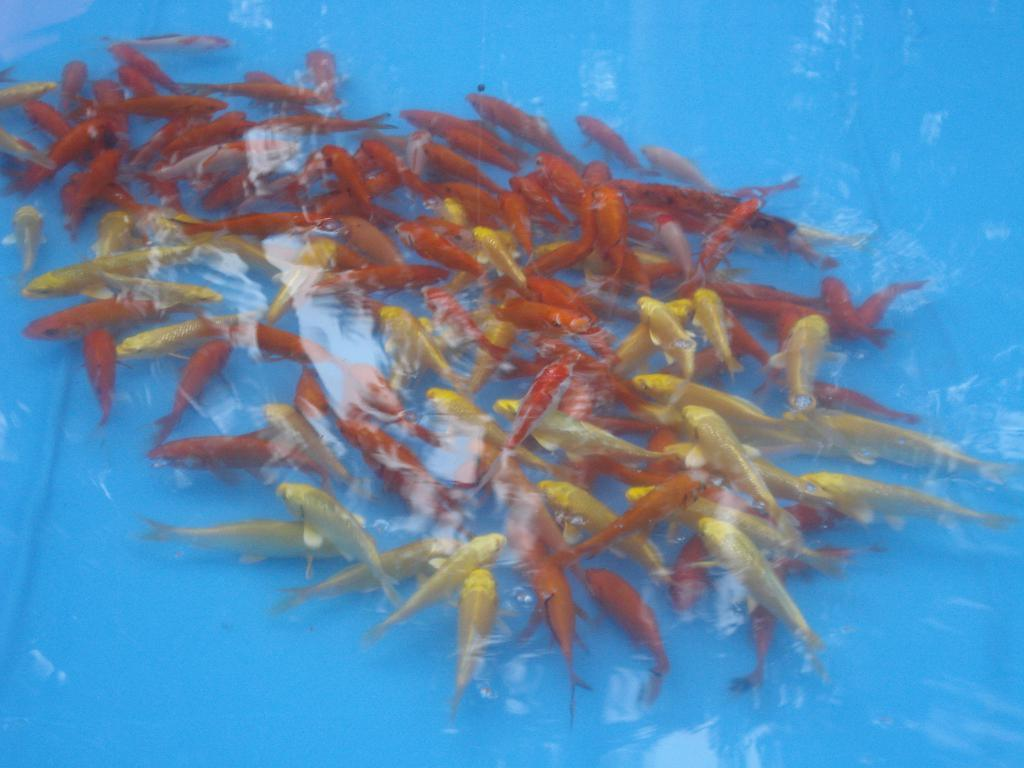What type of animals can be seen in the image? There are fishes in the image. What colors are the fishes in the image? The fishes are orange, yellow, and gold in color. What color is the background of the image? The background of the image is blue. How many blades are visible in the image? There are no blades present in the image; it features fishes in various colors against a blue background. Can you tell me how many mice are swimming with the fishes in the image? There are no mice present in the image; it only features fishes. 